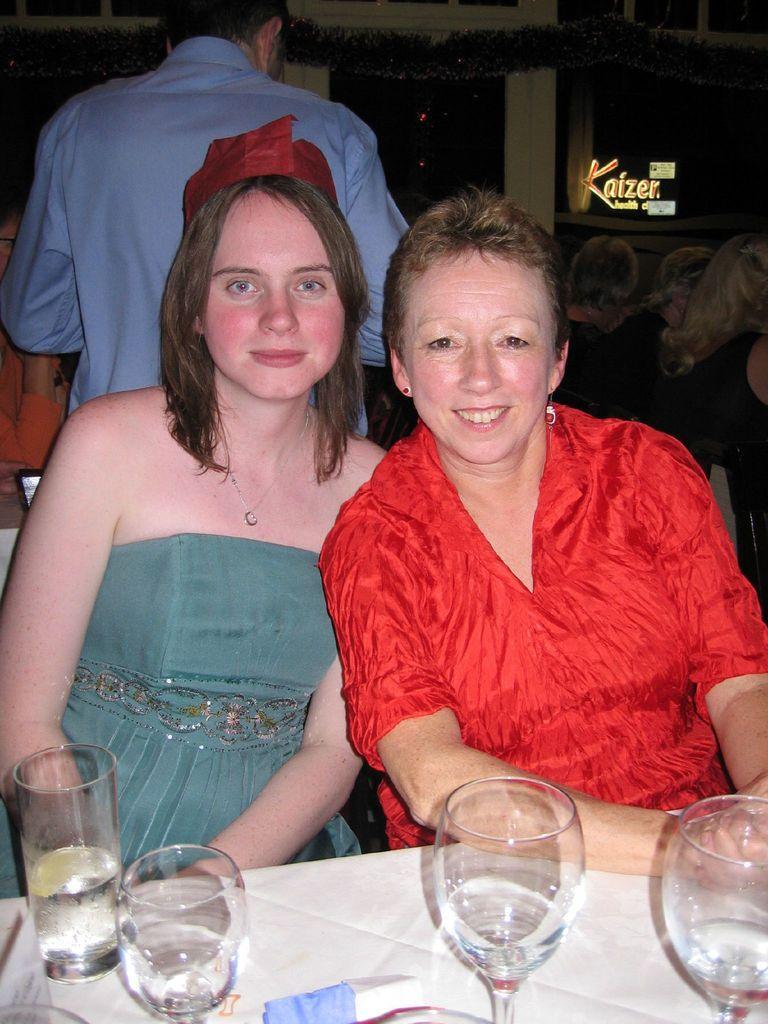Please provide a concise description of this image. At the bottom of the image there is a table, on the table there are some glasses. Behind the table two women are sitting and smiling. Behind them a person is standing. In front him few people are sitting. At the top of the image there is wall. 